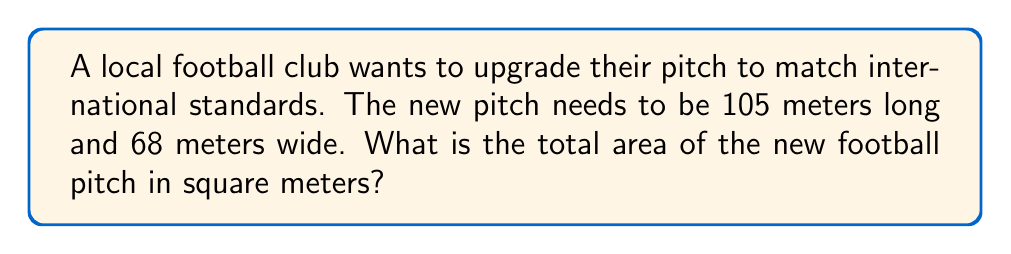Give your solution to this math problem. To find the area of a rectangular football pitch, we need to multiply its length by its width. Let's break it down step-by-step:

1. Given dimensions:
   Length ($l$) = 105 meters
   Width ($w$) = 68 meters

2. The formula for the area of a rectangle is:
   $$A = l \times w$$

3. Plug in the values:
   $$A = 105 \text{ m} \times 68 \text{ m}$$

4. Multiply:
   $$A = 7,140 \text{ m}^2$$

The area of the football pitch is 7,140 square meters.
Answer: $7,140 \text{ m}^2$ 